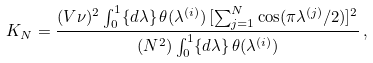Convert formula to latex. <formula><loc_0><loc_0><loc_500><loc_500>K _ { N } = \frac { ( V \nu ) ^ { 2 } \int _ { 0 } ^ { 1 } \{ d \lambda \} \, \theta ( \lambda ^ { ( i ) } ) \, [ \sum _ { j = 1 } ^ { N } \cos ( \pi \lambda ^ { ( j ) } / 2 ) ] ^ { 2 } } { ( N ^ { 2 } ) \int _ { 0 } ^ { 1 } \{ d \lambda \} \, \theta ( \lambda ^ { ( i ) } ) } \, ,</formula> 